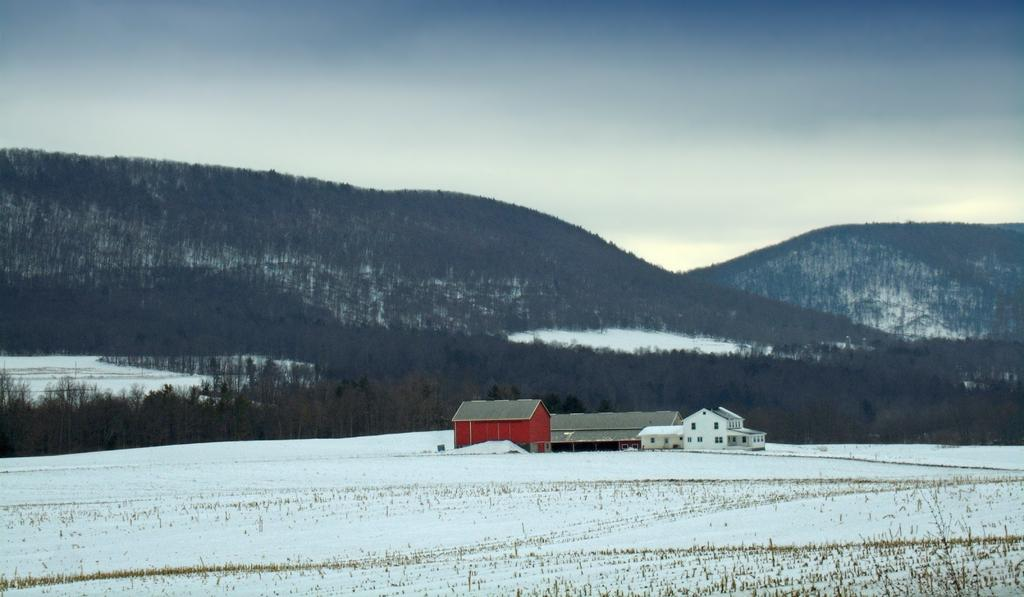What is present in the foreground of the image? There is snow and grass in the foreground of the image. What can be seen in the middle of the image? There are buildings in the middle of the image. What is visible in the background of the image? There are trees, mountains, and the sky in the background of the image. What color is the rest that is visible in the image? There is no rest present in the image; it is a landscape scene with snow, grass, buildings, trees, mountains, and the sky. What show is being performed in the image? There is no show being performed in the image; it is a still landscape scene. 